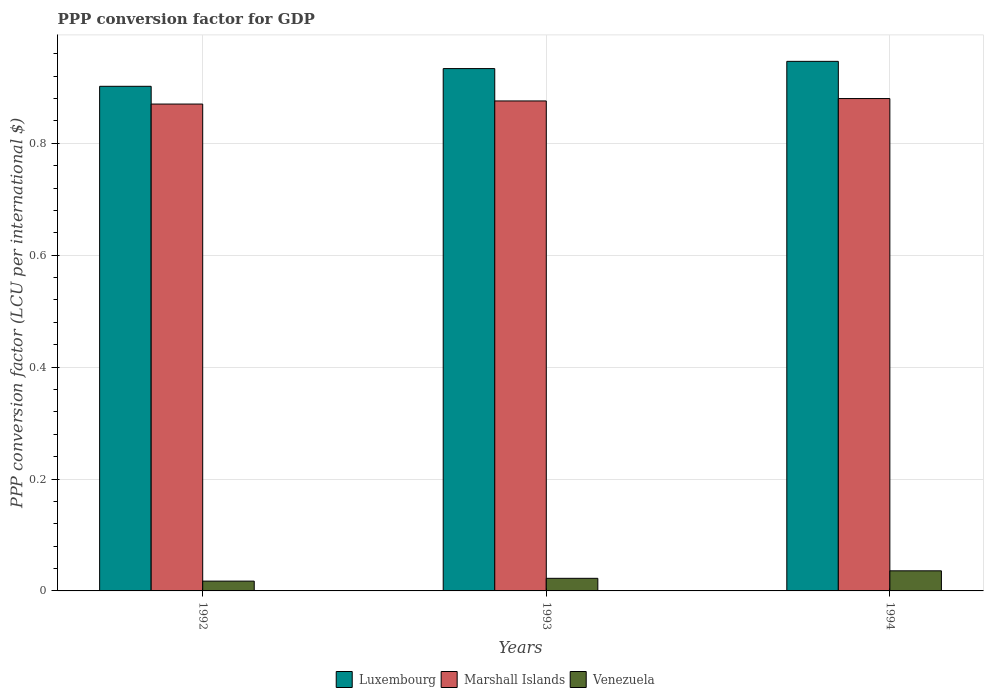Are the number of bars on each tick of the X-axis equal?
Make the answer very short. Yes. What is the label of the 2nd group of bars from the left?
Your answer should be very brief. 1993. What is the PPP conversion factor for GDP in Luxembourg in 1992?
Your answer should be compact. 0.9. Across all years, what is the maximum PPP conversion factor for GDP in Marshall Islands?
Offer a very short reply. 0.88. Across all years, what is the minimum PPP conversion factor for GDP in Marshall Islands?
Your answer should be compact. 0.87. In which year was the PPP conversion factor for GDP in Luxembourg maximum?
Provide a succinct answer. 1994. In which year was the PPP conversion factor for GDP in Marshall Islands minimum?
Your response must be concise. 1992. What is the total PPP conversion factor for GDP in Venezuela in the graph?
Offer a very short reply. 0.08. What is the difference between the PPP conversion factor for GDP in Venezuela in 1992 and that in 1994?
Offer a terse response. -0.02. What is the difference between the PPP conversion factor for GDP in Venezuela in 1992 and the PPP conversion factor for GDP in Luxembourg in 1993?
Give a very brief answer. -0.92. What is the average PPP conversion factor for GDP in Marshall Islands per year?
Give a very brief answer. 0.88. In the year 1994, what is the difference between the PPP conversion factor for GDP in Luxembourg and PPP conversion factor for GDP in Venezuela?
Provide a succinct answer. 0.91. In how many years, is the PPP conversion factor for GDP in Marshall Islands greater than 0.32 LCU?
Ensure brevity in your answer.  3. What is the ratio of the PPP conversion factor for GDP in Luxembourg in 1992 to that in 1994?
Provide a succinct answer. 0.95. What is the difference between the highest and the second highest PPP conversion factor for GDP in Marshall Islands?
Give a very brief answer. 0. What is the difference between the highest and the lowest PPP conversion factor for GDP in Luxembourg?
Offer a very short reply. 0.04. Is the sum of the PPP conversion factor for GDP in Marshall Islands in 1992 and 1994 greater than the maximum PPP conversion factor for GDP in Luxembourg across all years?
Offer a terse response. Yes. What does the 1st bar from the left in 1993 represents?
Provide a short and direct response. Luxembourg. What does the 1st bar from the right in 1992 represents?
Ensure brevity in your answer.  Venezuela. Is it the case that in every year, the sum of the PPP conversion factor for GDP in Marshall Islands and PPP conversion factor for GDP in Luxembourg is greater than the PPP conversion factor for GDP in Venezuela?
Your answer should be very brief. Yes. How many years are there in the graph?
Your response must be concise. 3. Does the graph contain grids?
Your answer should be compact. Yes. How many legend labels are there?
Keep it short and to the point. 3. How are the legend labels stacked?
Make the answer very short. Horizontal. What is the title of the graph?
Make the answer very short. PPP conversion factor for GDP. Does "Albania" appear as one of the legend labels in the graph?
Keep it short and to the point. No. What is the label or title of the X-axis?
Your answer should be very brief. Years. What is the label or title of the Y-axis?
Make the answer very short. PPP conversion factor (LCU per international $). What is the PPP conversion factor (LCU per international $) in Luxembourg in 1992?
Provide a succinct answer. 0.9. What is the PPP conversion factor (LCU per international $) of Marshall Islands in 1992?
Make the answer very short. 0.87. What is the PPP conversion factor (LCU per international $) of Venezuela in 1992?
Keep it short and to the point. 0.02. What is the PPP conversion factor (LCU per international $) in Luxembourg in 1993?
Give a very brief answer. 0.93. What is the PPP conversion factor (LCU per international $) in Marshall Islands in 1993?
Provide a succinct answer. 0.88. What is the PPP conversion factor (LCU per international $) of Venezuela in 1993?
Your answer should be very brief. 0.02. What is the PPP conversion factor (LCU per international $) of Luxembourg in 1994?
Ensure brevity in your answer.  0.95. What is the PPP conversion factor (LCU per international $) in Marshall Islands in 1994?
Make the answer very short. 0.88. What is the PPP conversion factor (LCU per international $) of Venezuela in 1994?
Provide a short and direct response. 0.04. Across all years, what is the maximum PPP conversion factor (LCU per international $) of Luxembourg?
Give a very brief answer. 0.95. Across all years, what is the maximum PPP conversion factor (LCU per international $) in Marshall Islands?
Your answer should be compact. 0.88. Across all years, what is the maximum PPP conversion factor (LCU per international $) in Venezuela?
Give a very brief answer. 0.04. Across all years, what is the minimum PPP conversion factor (LCU per international $) in Luxembourg?
Provide a short and direct response. 0.9. Across all years, what is the minimum PPP conversion factor (LCU per international $) of Marshall Islands?
Give a very brief answer. 0.87. Across all years, what is the minimum PPP conversion factor (LCU per international $) of Venezuela?
Provide a short and direct response. 0.02. What is the total PPP conversion factor (LCU per international $) of Luxembourg in the graph?
Your answer should be very brief. 2.78. What is the total PPP conversion factor (LCU per international $) in Marshall Islands in the graph?
Your answer should be very brief. 2.63. What is the total PPP conversion factor (LCU per international $) in Venezuela in the graph?
Your answer should be very brief. 0.08. What is the difference between the PPP conversion factor (LCU per international $) of Luxembourg in 1992 and that in 1993?
Your answer should be compact. -0.03. What is the difference between the PPP conversion factor (LCU per international $) of Marshall Islands in 1992 and that in 1993?
Your answer should be compact. -0.01. What is the difference between the PPP conversion factor (LCU per international $) in Venezuela in 1992 and that in 1993?
Offer a very short reply. -0.01. What is the difference between the PPP conversion factor (LCU per international $) in Luxembourg in 1992 and that in 1994?
Ensure brevity in your answer.  -0.04. What is the difference between the PPP conversion factor (LCU per international $) of Marshall Islands in 1992 and that in 1994?
Provide a short and direct response. -0.01. What is the difference between the PPP conversion factor (LCU per international $) of Venezuela in 1992 and that in 1994?
Ensure brevity in your answer.  -0.02. What is the difference between the PPP conversion factor (LCU per international $) in Luxembourg in 1993 and that in 1994?
Provide a succinct answer. -0.01. What is the difference between the PPP conversion factor (LCU per international $) of Marshall Islands in 1993 and that in 1994?
Your response must be concise. -0. What is the difference between the PPP conversion factor (LCU per international $) in Venezuela in 1993 and that in 1994?
Your response must be concise. -0.01. What is the difference between the PPP conversion factor (LCU per international $) in Luxembourg in 1992 and the PPP conversion factor (LCU per international $) in Marshall Islands in 1993?
Keep it short and to the point. 0.03. What is the difference between the PPP conversion factor (LCU per international $) of Luxembourg in 1992 and the PPP conversion factor (LCU per international $) of Venezuela in 1993?
Your answer should be very brief. 0.88. What is the difference between the PPP conversion factor (LCU per international $) in Marshall Islands in 1992 and the PPP conversion factor (LCU per international $) in Venezuela in 1993?
Give a very brief answer. 0.85. What is the difference between the PPP conversion factor (LCU per international $) in Luxembourg in 1992 and the PPP conversion factor (LCU per international $) in Marshall Islands in 1994?
Your response must be concise. 0.02. What is the difference between the PPP conversion factor (LCU per international $) in Luxembourg in 1992 and the PPP conversion factor (LCU per international $) in Venezuela in 1994?
Keep it short and to the point. 0.87. What is the difference between the PPP conversion factor (LCU per international $) of Marshall Islands in 1992 and the PPP conversion factor (LCU per international $) of Venezuela in 1994?
Keep it short and to the point. 0.83. What is the difference between the PPP conversion factor (LCU per international $) in Luxembourg in 1993 and the PPP conversion factor (LCU per international $) in Marshall Islands in 1994?
Keep it short and to the point. 0.05. What is the difference between the PPP conversion factor (LCU per international $) of Luxembourg in 1993 and the PPP conversion factor (LCU per international $) of Venezuela in 1994?
Ensure brevity in your answer.  0.9. What is the difference between the PPP conversion factor (LCU per international $) of Marshall Islands in 1993 and the PPP conversion factor (LCU per international $) of Venezuela in 1994?
Your response must be concise. 0.84. What is the average PPP conversion factor (LCU per international $) of Luxembourg per year?
Keep it short and to the point. 0.93. What is the average PPP conversion factor (LCU per international $) of Marshall Islands per year?
Offer a terse response. 0.88. What is the average PPP conversion factor (LCU per international $) of Venezuela per year?
Your response must be concise. 0.03. In the year 1992, what is the difference between the PPP conversion factor (LCU per international $) in Luxembourg and PPP conversion factor (LCU per international $) in Marshall Islands?
Keep it short and to the point. 0.03. In the year 1992, what is the difference between the PPP conversion factor (LCU per international $) of Luxembourg and PPP conversion factor (LCU per international $) of Venezuela?
Your answer should be compact. 0.88. In the year 1992, what is the difference between the PPP conversion factor (LCU per international $) of Marshall Islands and PPP conversion factor (LCU per international $) of Venezuela?
Provide a short and direct response. 0.85. In the year 1993, what is the difference between the PPP conversion factor (LCU per international $) of Luxembourg and PPP conversion factor (LCU per international $) of Marshall Islands?
Offer a terse response. 0.06. In the year 1993, what is the difference between the PPP conversion factor (LCU per international $) of Luxembourg and PPP conversion factor (LCU per international $) of Venezuela?
Provide a succinct answer. 0.91. In the year 1993, what is the difference between the PPP conversion factor (LCU per international $) in Marshall Islands and PPP conversion factor (LCU per international $) in Venezuela?
Provide a succinct answer. 0.85. In the year 1994, what is the difference between the PPP conversion factor (LCU per international $) of Luxembourg and PPP conversion factor (LCU per international $) of Marshall Islands?
Offer a very short reply. 0.07. In the year 1994, what is the difference between the PPP conversion factor (LCU per international $) of Luxembourg and PPP conversion factor (LCU per international $) of Venezuela?
Offer a terse response. 0.91. In the year 1994, what is the difference between the PPP conversion factor (LCU per international $) of Marshall Islands and PPP conversion factor (LCU per international $) of Venezuela?
Give a very brief answer. 0.84. What is the ratio of the PPP conversion factor (LCU per international $) of Luxembourg in 1992 to that in 1993?
Provide a succinct answer. 0.97. What is the ratio of the PPP conversion factor (LCU per international $) in Venezuela in 1992 to that in 1993?
Your answer should be compact. 0.78. What is the ratio of the PPP conversion factor (LCU per international $) of Luxembourg in 1992 to that in 1994?
Give a very brief answer. 0.95. What is the ratio of the PPP conversion factor (LCU per international $) in Venezuela in 1992 to that in 1994?
Provide a succinct answer. 0.49. What is the ratio of the PPP conversion factor (LCU per international $) of Luxembourg in 1993 to that in 1994?
Offer a very short reply. 0.99. What is the ratio of the PPP conversion factor (LCU per international $) in Marshall Islands in 1993 to that in 1994?
Offer a terse response. 1. What is the ratio of the PPP conversion factor (LCU per international $) in Venezuela in 1993 to that in 1994?
Make the answer very short. 0.63. What is the difference between the highest and the second highest PPP conversion factor (LCU per international $) of Luxembourg?
Your answer should be very brief. 0.01. What is the difference between the highest and the second highest PPP conversion factor (LCU per international $) of Marshall Islands?
Your response must be concise. 0. What is the difference between the highest and the second highest PPP conversion factor (LCU per international $) of Venezuela?
Keep it short and to the point. 0.01. What is the difference between the highest and the lowest PPP conversion factor (LCU per international $) of Luxembourg?
Give a very brief answer. 0.04. What is the difference between the highest and the lowest PPP conversion factor (LCU per international $) in Marshall Islands?
Provide a succinct answer. 0.01. What is the difference between the highest and the lowest PPP conversion factor (LCU per international $) in Venezuela?
Make the answer very short. 0.02. 